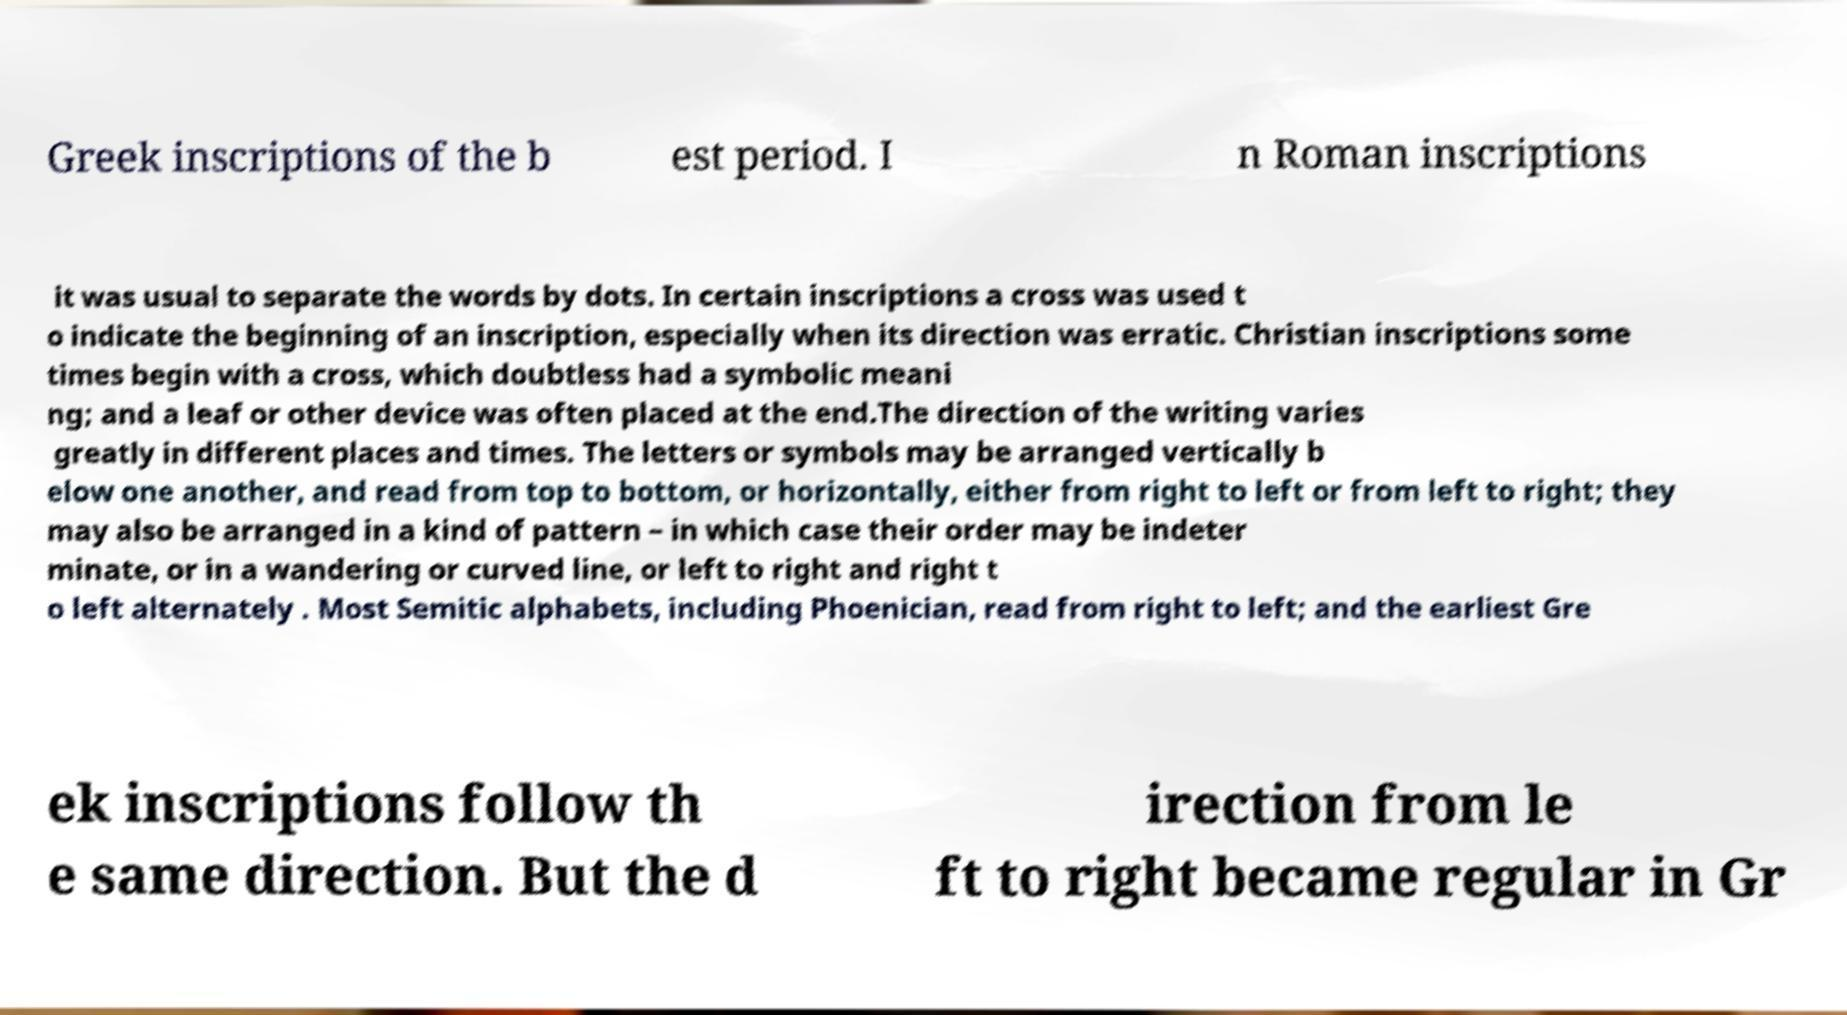Please identify and transcribe the text found in this image. Greek inscriptions of the b est period. I n Roman inscriptions it was usual to separate the words by dots. In certain inscriptions a cross was used t o indicate the beginning of an inscription, especially when its direction was erratic. Christian inscriptions some times begin with a cross, which doubtless had a symbolic meani ng; and a leaf or other device was often placed at the end.The direction of the writing varies greatly in different places and times. The letters or symbols may be arranged vertically b elow one another, and read from top to bottom, or horizontally, either from right to left or from left to right; they may also be arranged in a kind of pattern – in which case their order may be indeter minate, or in a wandering or curved line, or left to right and right t o left alternately . Most Semitic alphabets, including Phoenician, read from right to left; and the earliest Gre ek inscriptions follow th e same direction. But the d irection from le ft to right became regular in Gr 